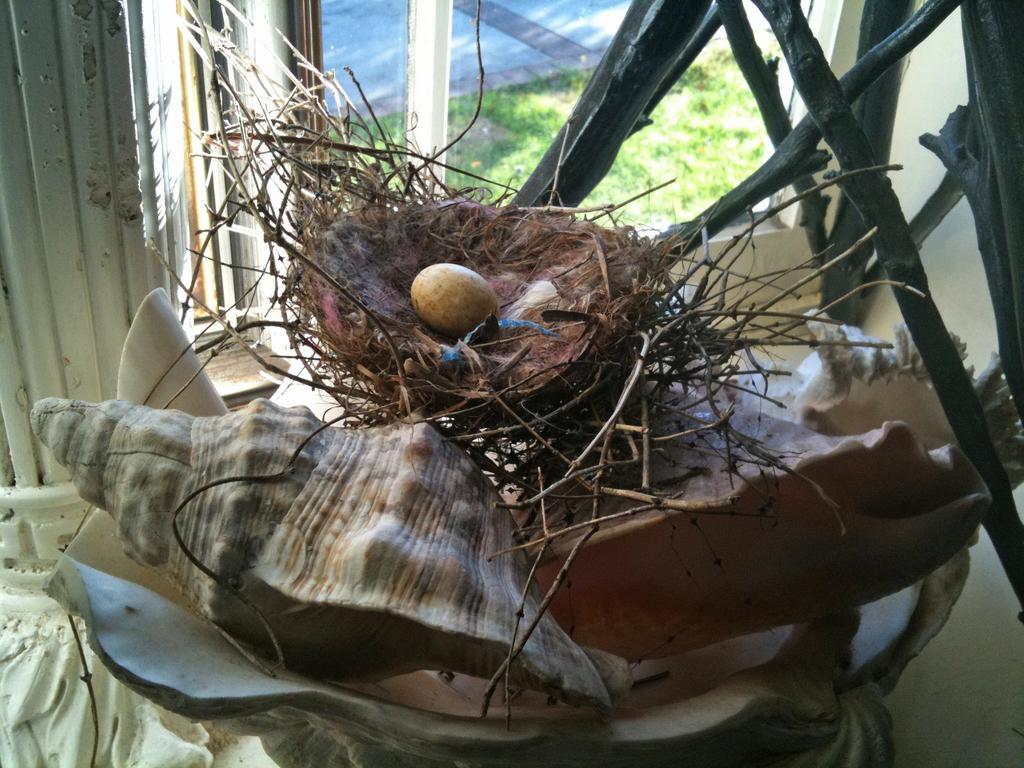Can you describe this image briefly? In this image I can see the shell. I can see an egg in the nest. On the right side, I can see some sticks. In the background, I can see the grass behind the window. 